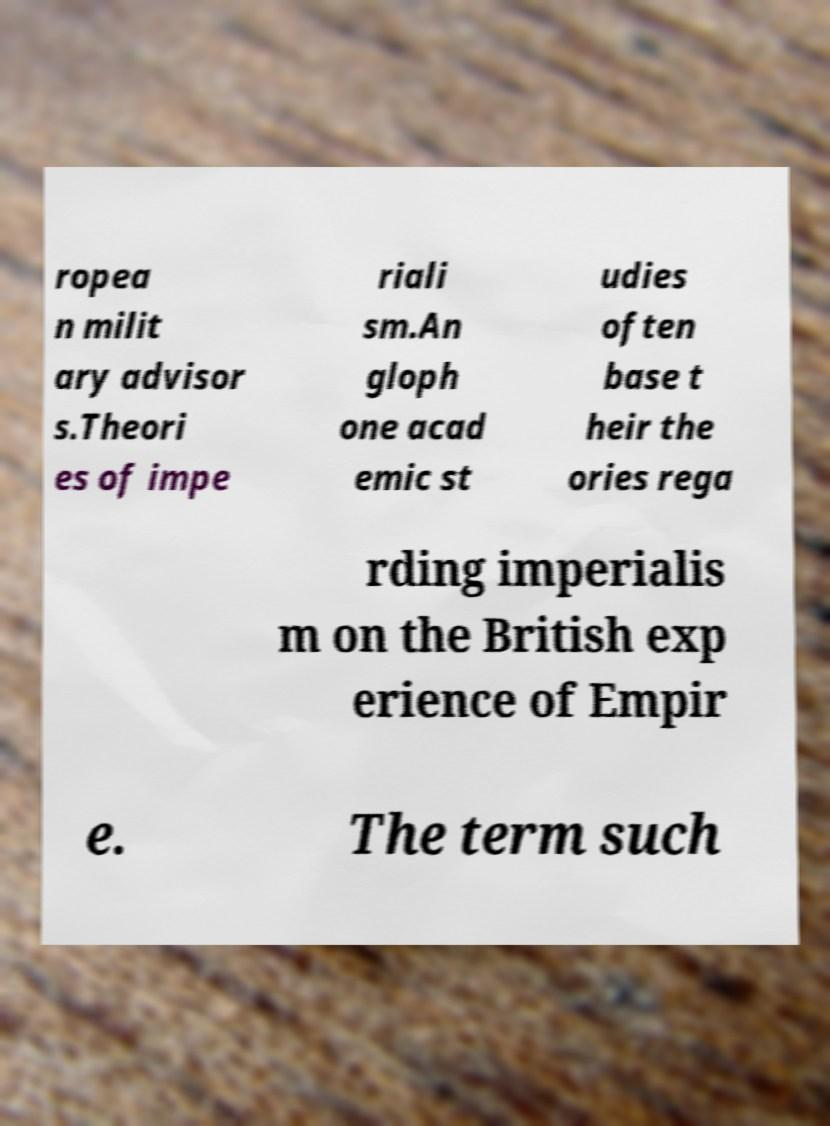Please read and relay the text visible in this image. What does it say? ropea n milit ary advisor s.Theori es of impe riali sm.An gloph one acad emic st udies often base t heir the ories rega rding imperialis m on the British exp erience of Empir e. The term such 